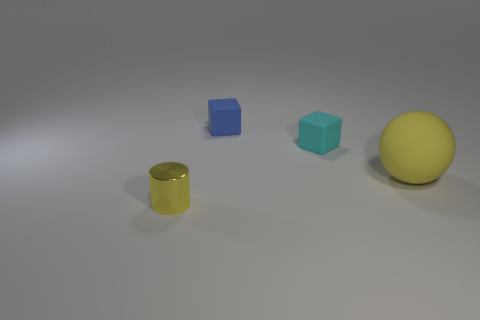Do the rubber sphere and the rubber block that is behind the cyan rubber block have the same size?
Keep it short and to the point. No. What number of other things have the same size as the cyan thing?
Your answer should be very brief. 2. Is the number of large yellow balls behind the small cyan rubber block less than the number of small gray spheres?
Your answer should be very brief. No. What size is the yellow thing that is right of the thing that is in front of the large yellow matte ball?
Give a very brief answer. Large. How many objects are either small green spheres or matte things?
Offer a terse response. 3. Are there any other large objects that have the same color as the metal thing?
Provide a short and direct response. Yes. Is the number of tiny cyan blocks less than the number of tiny rubber blocks?
Offer a very short reply. Yes. What number of things are either green metal cylinders or yellow objects to the right of the yellow shiny cylinder?
Your answer should be very brief. 1. Is there a tiny cube that has the same material as the tiny cyan thing?
Ensure brevity in your answer.  Yes. There is a yellow cylinder that is the same size as the blue matte thing; what is it made of?
Provide a short and direct response. Metal. 